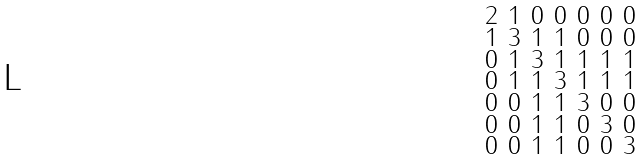<formula> <loc_0><loc_0><loc_500><loc_500>\begin{smallmatrix} 2 & 1 & 0 & 0 & 0 & 0 & 0 \\ 1 & 3 & 1 & 1 & 0 & 0 & 0 \\ 0 & 1 & 3 & 1 & 1 & 1 & 1 \\ 0 & 1 & 1 & 3 & 1 & 1 & 1 \\ 0 & 0 & 1 & 1 & 3 & 0 & 0 \\ 0 & 0 & 1 & 1 & 0 & 3 & 0 \\ 0 & 0 & 1 & 1 & 0 & 0 & 3 \end{smallmatrix}</formula> 